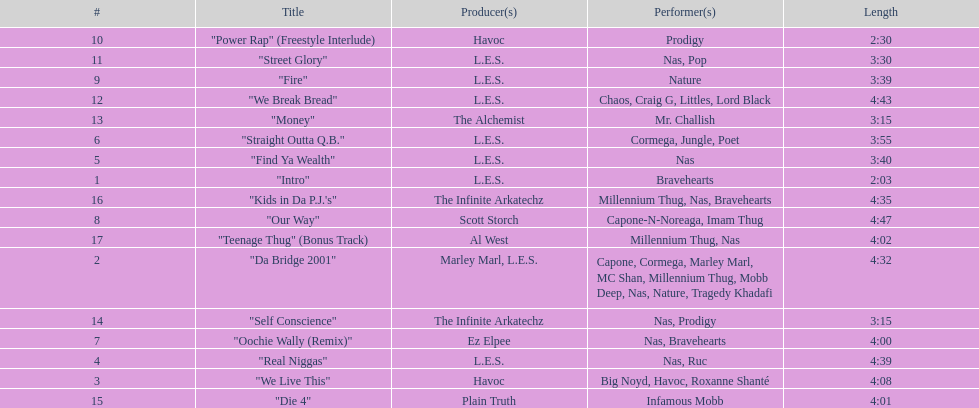How long is the shortest song on the album? 2:03. 